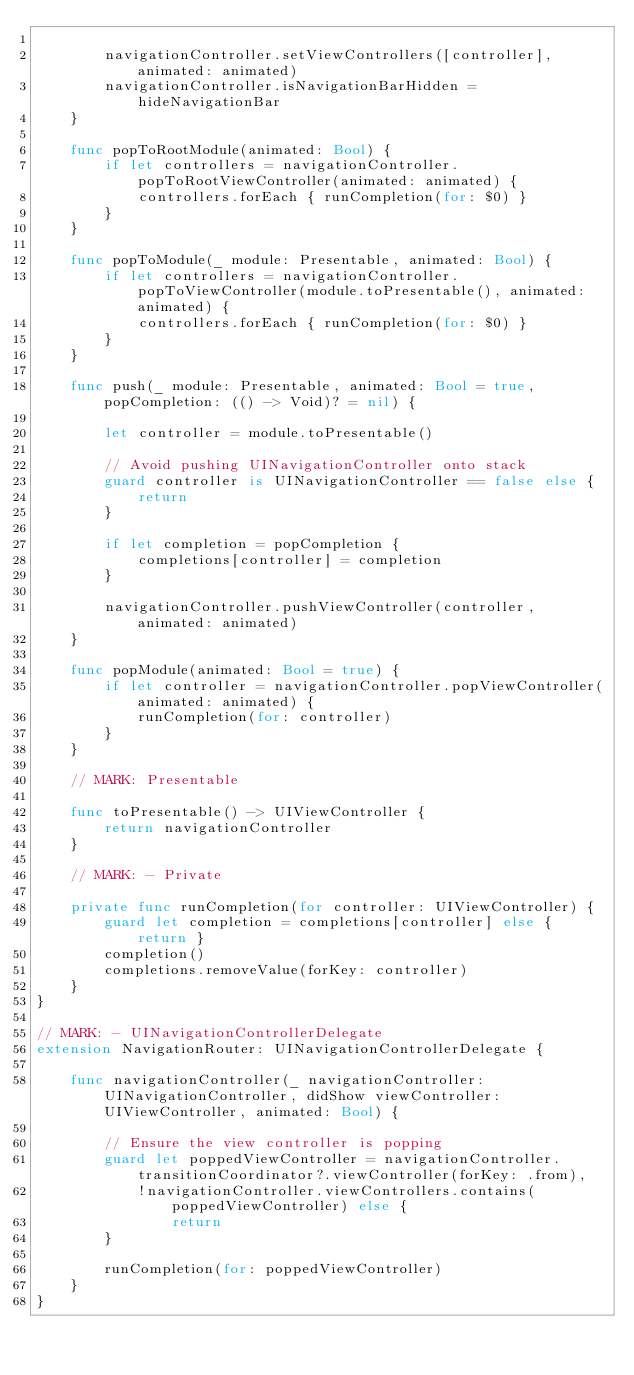Convert code to text. <code><loc_0><loc_0><loc_500><loc_500><_Swift_>        
        navigationController.setViewControllers([controller], animated: animated)
        navigationController.isNavigationBarHidden = hideNavigationBar
    }
    
    func popToRootModule(animated: Bool) {
        if let controllers = navigationController.popToRootViewController(animated: animated) {
            controllers.forEach { runCompletion(for: $0) }
        }
    }
    
    func popToModule(_ module: Presentable, animated: Bool) {
        if let controllers = navigationController.popToViewController(module.toPresentable(), animated: animated) {
            controllers.forEach { runCompletion(for: $0) }
        }
    }
    
    func push(_ module: Presentable, animated: Bool = true, popCompletion: (() -> Void)? = nil) {
        
        let controller = module.toPresentable()
        
        // Avoid pushing UINavigationController onto stack
        guard controller is UINavigationController == false else {
            return
        }
        
        if let completion = popCompletion {
            completions[controller] = completion
        }
        
        navigationController.pushViewController(controller, animated: animated)        
    }
    
    func popModule(animated: Bool = true) {
        if let controller = navigationController.popViewController(animated: animated) {
            runCompletion(for: controller)
        }
    }
        
    // MARK: Presentable
    
    func toPresentable() -> UIViewController {
        return navigationController
    }
    
    // MARK: - Private
    
    private func runCompletion(for controller: UIViewController) {
        guard let completion = completions[controller] else { return }
        completion()
        completions.removeValue(forKey: controller)
    }
}

// MARK: - UINavigationControllerDelegate
extension NavigationRouter: UINavigationControllerDelegate {
    
    func navigationController(_ navigationController: UINavigationController, didShow viewController: UIViewController, animated: Bool) {
        
        // Ensure the view controller is popping
        guard let poppedViewController = navigationController.transitionCoordinator?.viewController(forKey: .from),
            !navigationController.viewControllers.contains(poppedViewController) else {
                return
        }
        
        runCompletion(for: poppedViewController)
    }
}
</code> 